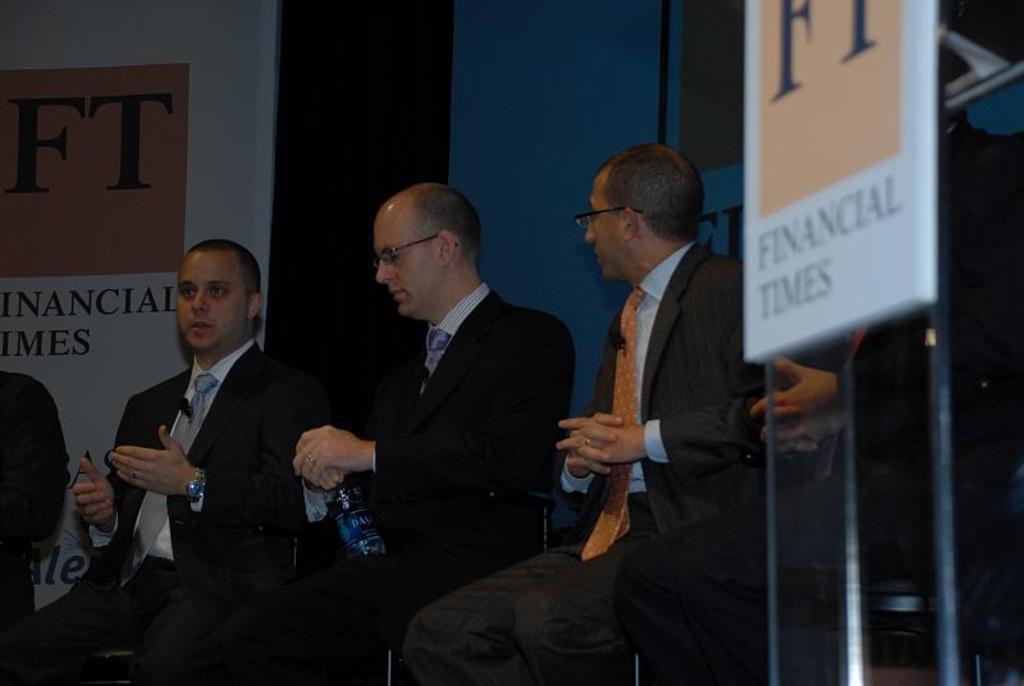In one or two sentences, can you explain what this image depicts? In this image we can see some people, bottle and other objects. In the background of the image there is a wall and boards. On the right side of the image there is a name board with pole. 